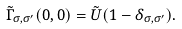Convert formula to latex. <formula><loc_0><loc_0><loc_500><loc_500>\tilde { \Gamma } _ { \sigma , \sigma ^ { \prime } } ( 0 , 0 ) = \tilde { U } ( 1 - \delta _ { \sigma , \sigma ^ { \prime } } ) .</formula> 